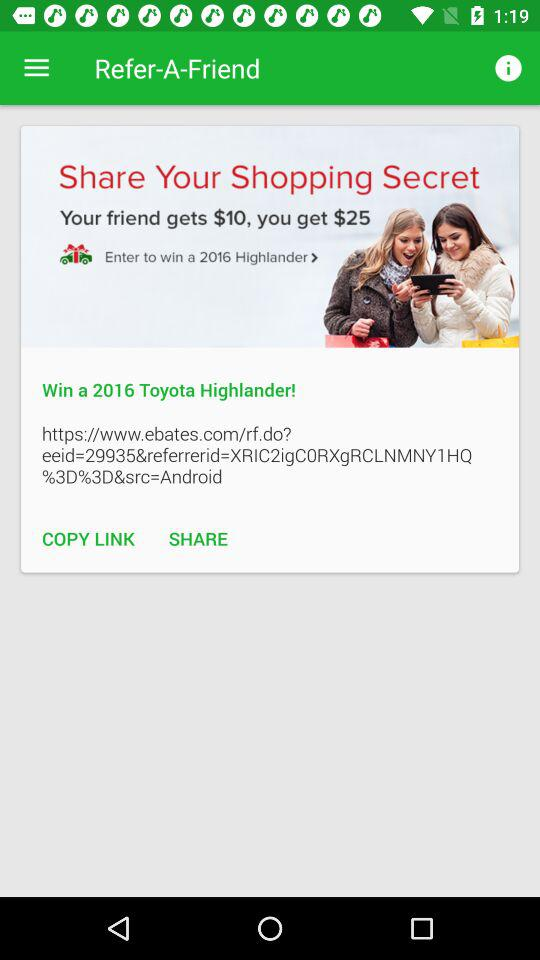What is the winning prize? The winning prize is "2016 Toyota Highlander". 